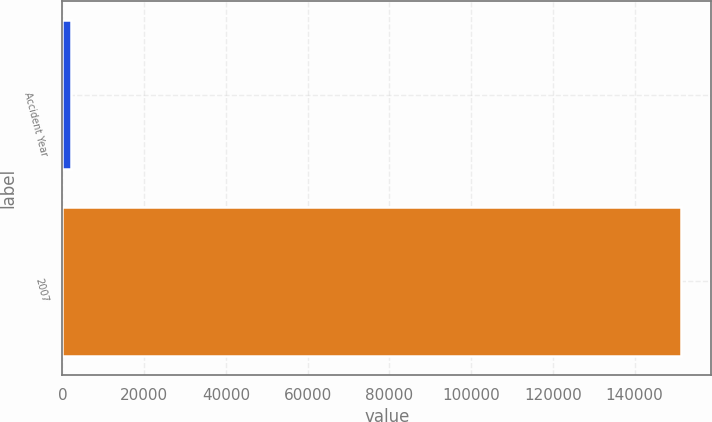Convert chart to OTSL. <chart><loc_0><loc_0><loc_500><loc_500><bar_chart><fcel>Accident Year<fcel>2007<nl><fcel>2010<fcel>151243<nl></chart> 